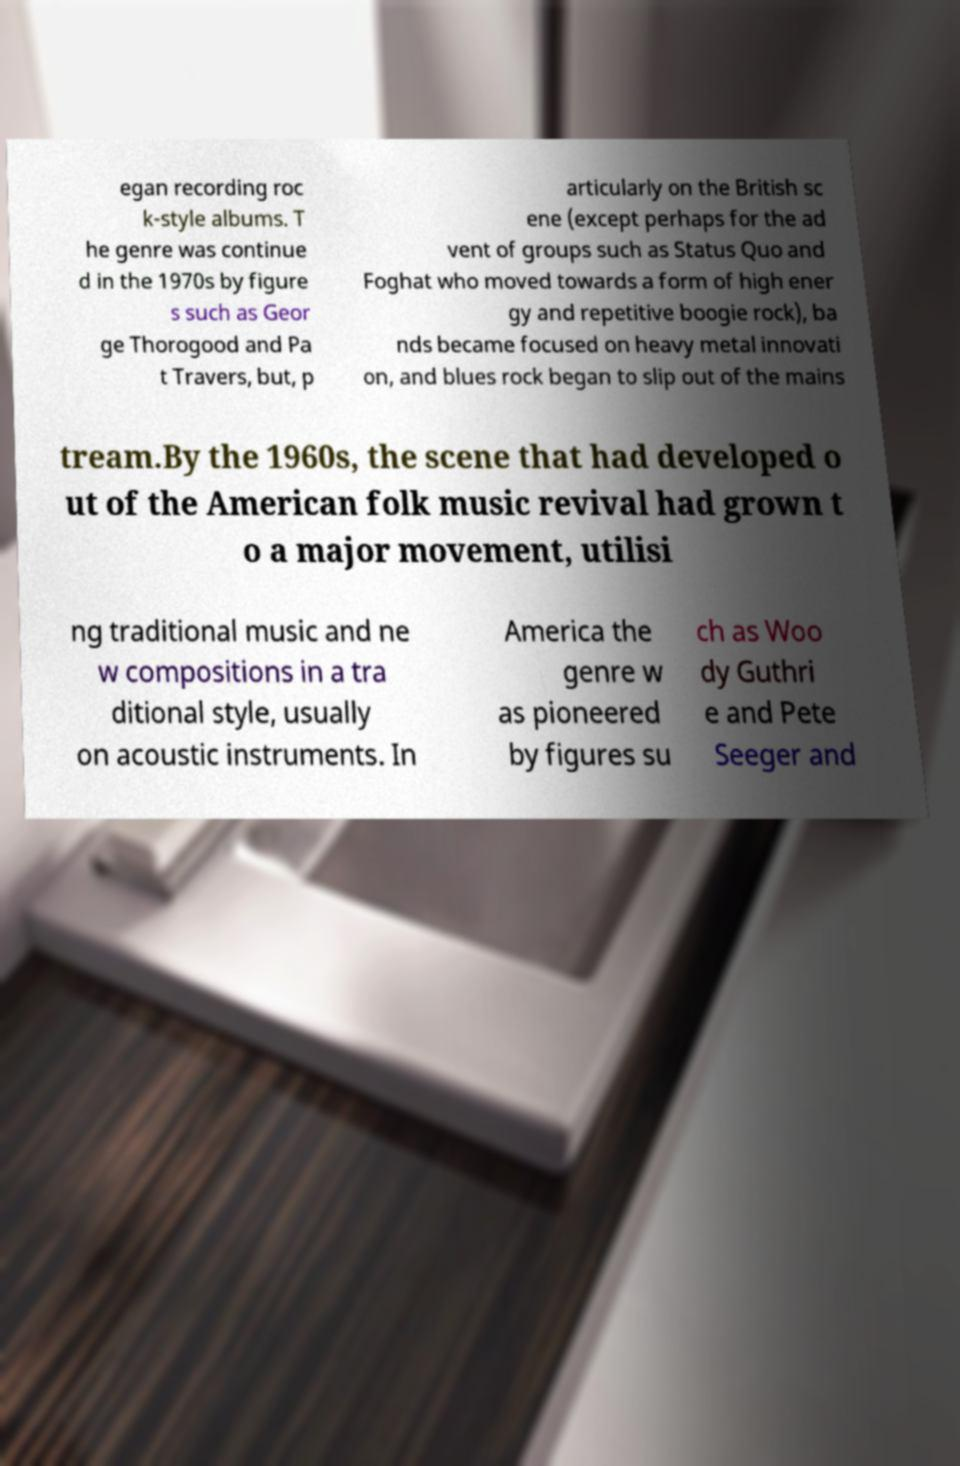There's text embedded in this image that I need extracted. Can you transcribe it verbatim? egan recording roc k-style albums. T he genre was continue d in the 1970s by figure s such as Geor ge Thorogood and Pa t Travers, but, p articularly on the British sc ene (except perhaps for the ad vent of groups such as Status Quo and Foghat who moved towards a form of high ener gy and repetitive boogie rock), ba nds became focused on heavy metal innovati on, and blues rock began to slip out of the mains tream.By the 1960s, the scene that had developed o ut of the American folk music revival had grown t o a major movement, utilisi ng traditional music and ne w compositions in a tra ditional style, usually on acoustic instruments. In America the genre w as pioneered by figures su ch as Woo dy Guthri e and Pete Seeger and 